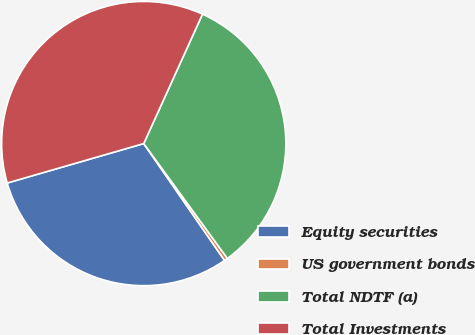Convert chart to OTSL. <chart><loc_0><loc_0><loc_500><loc_500><pie_chart><fcel>Equity securities<fcel>US government bonds<fcel>Total NDTF (a)<fcel>Total Investments<nl><fcel>30.15%<fcel>0.39%<fcel>33.2%<fcel>36.26%<nl></chart> 